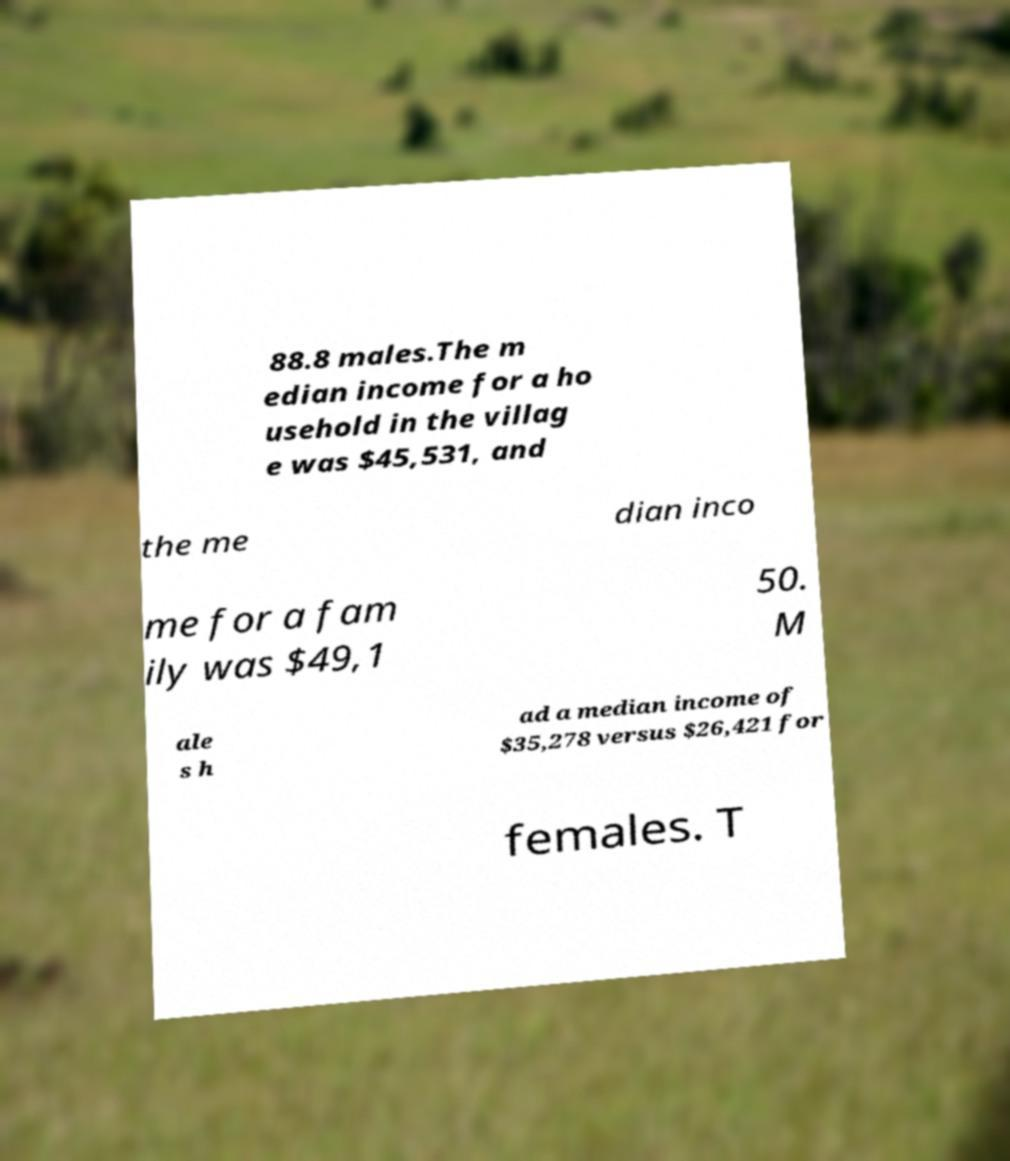I need the written content from this picture converted into text. Can you do that? 88.8 males.The m edian income for a ho usehold in the villag e was $45,531, and the me dian inco me for a fam ily was $49,1 50. M ale s h ad a median income of $35,278 versus $26,421 for females. T 